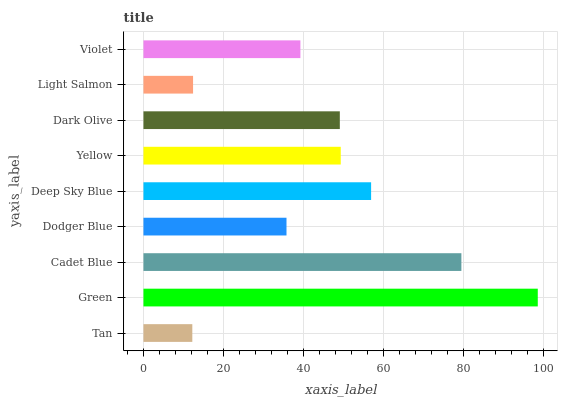Is Tan the minimum?
Answer yes or no. Yes. Is Green the maximum?
Answer yes or no. Yes. Is Cadet Blue the minimum?
Answer yes or no. No. Is Cadet Blue the maximum?
Answer yes or no. No. Is Green greater than Cadet Blue?
Answer yes or no. Yes. Is Cadet Blue less than Green?
Answer yes or no. Yes. Is Cadet Blue greater than Green?
Answer yes or no. No. Is Green less than Cadet Blue?
Answer yes or no. No. Is Dark Olive the high median?
Answer yes or no. Yes. Is Dark Olive the low median?
Answer yes or no. Yes. Is Green the high median?
Answer yes or no. No. Is Green the low median?
Answer yes or no. No. 